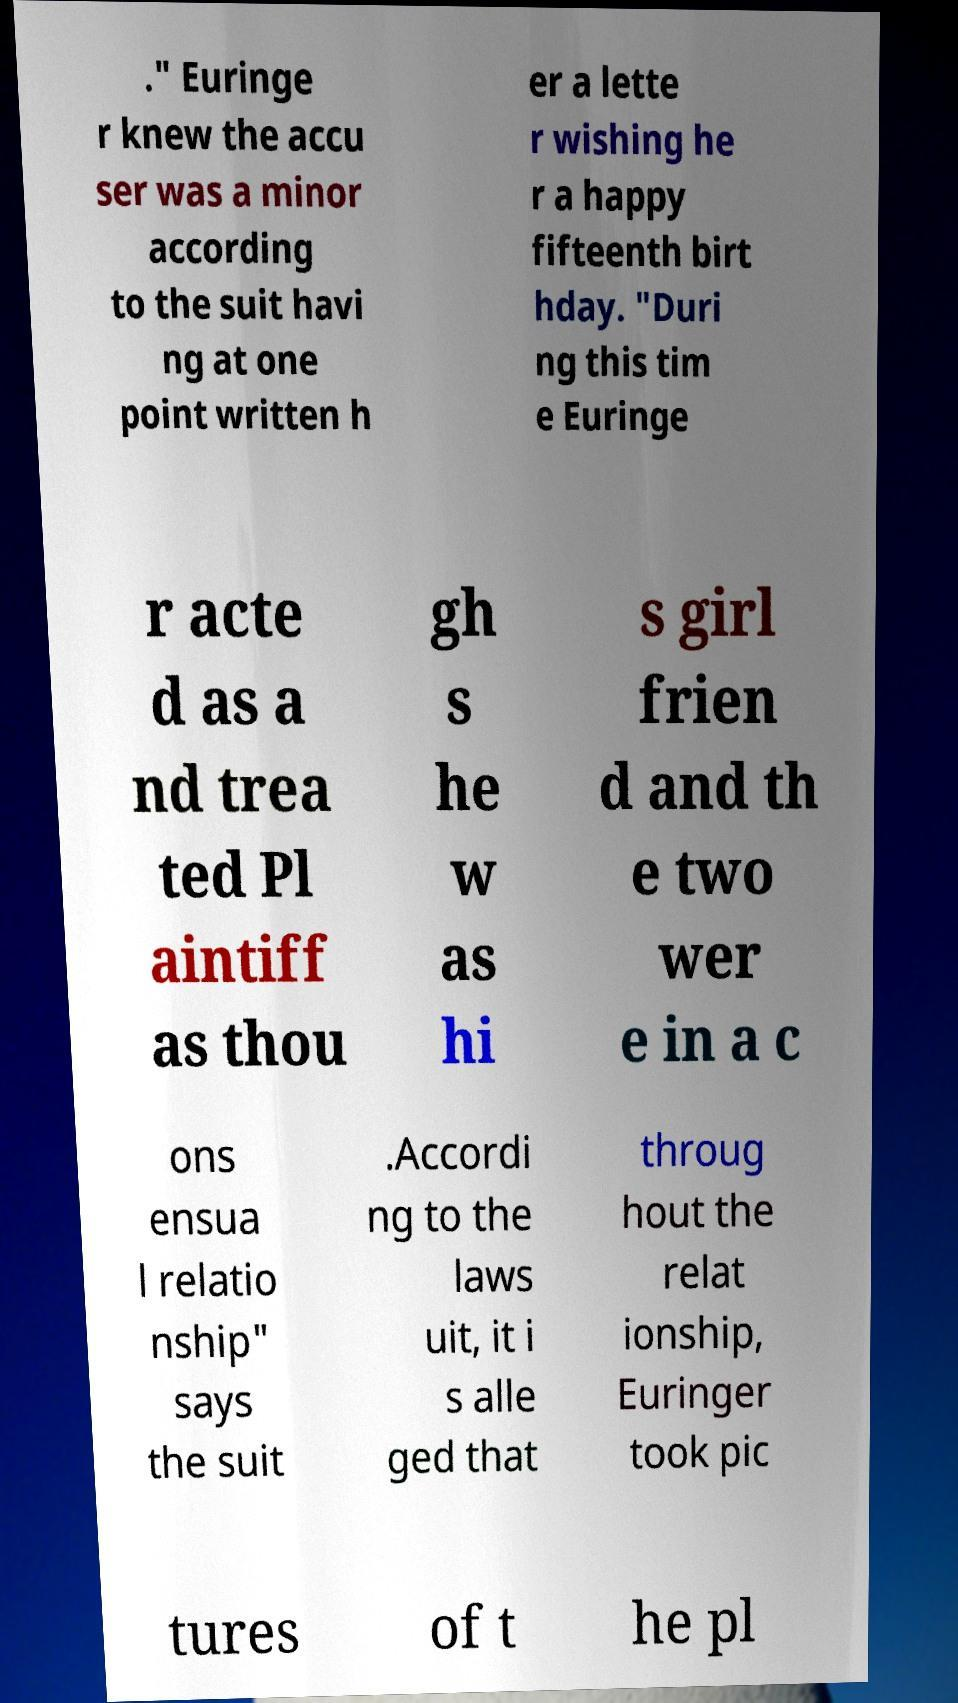There's text embedded in this image that I need extracted. Can you transcribe it verbatim? ." Euringe r knew the accu ser was a minor according to the suit havi ng at one point written h er a lette r wishing he r a happy fifteenth birt hday. "Duri ng this tim e Euringe r acte d as a nd trea ted Pl aintiff as thou gh s he w as hi s girl frien d and th e two wer e in a c ons ensua l relatio nship" says the suit .Accordi ng to the laws uit, it i s alle ged that throug hout the relat ionship, Euringer took pic tures of t he pl 